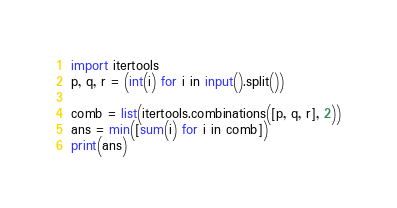Convert code to text. <code><loc_0><loc_0><loc_500><loc_500><_Python_>import itertools
p, q, r = (int(i) for i in input().split())  

comb = list(itertools.combinations([p, q, r], 2))
ans = min([sum(i) for i in comb])
print(ans)</code> 